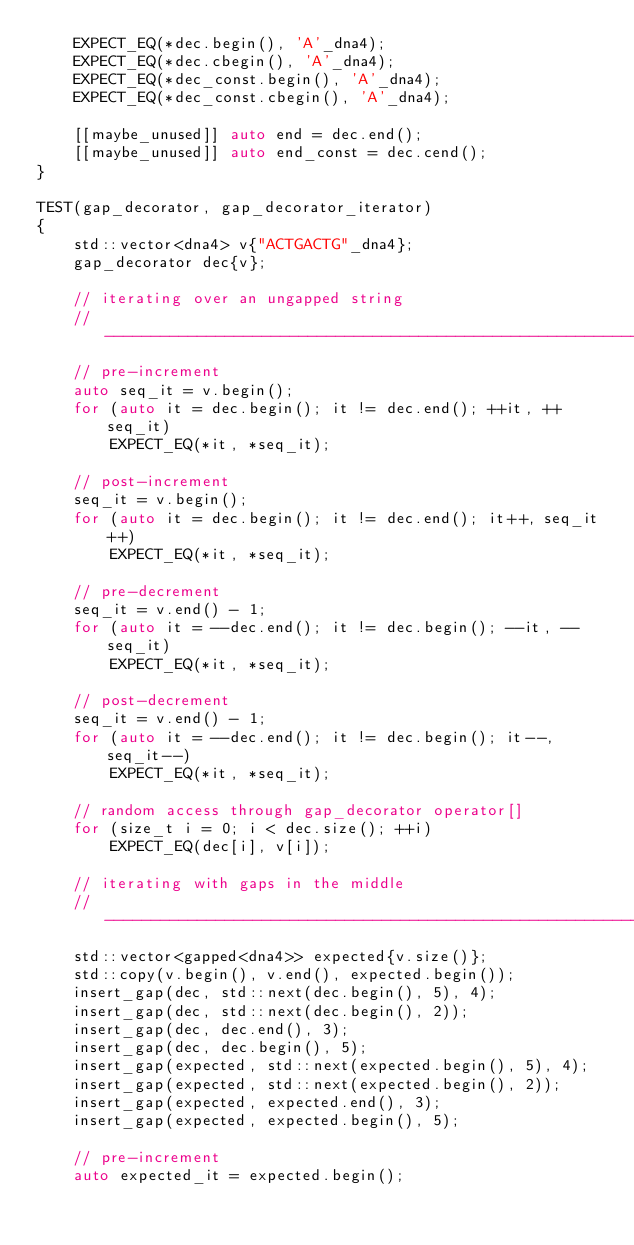<code> <loc_0><loc_0><loc_500><loc_500><_C++_>    EXPECT_EQ(*dec.begin(), 'A'_dna4);
    EXPECT_EQ(*dec.cbegin(), 'A'_dna4);
    EXPECT_EQ(*dec_const.begin(), 'A'_dna4);
    EXPECT_EQ(*dec_const.cbegin(), 'A'_dna4);

    [[maybe_unused]] auto end = dec.end();
    [[maybe_unused]] auto end_const = dec.cend();
}

TEST(gap_decorator, gap_decorator_iterator)
{
    std::vector<dna4> v{"ACTGACTG"_dna4};
    gap_decorator dec{v};

    // iterating over an ungapped string
    // -------------------------------------------------------------------------
    // pre-increment
    auto seq_it = v.begin();
    for (auto it = dec.begin(); it != dec.end(); ++it, ++seq_it)
        EXPECT_EQ(*it, *seq_it);

    // post-increment
    seq_it = v.begin();
    for (auto it = dec.begin(); it != dec.end(); it++, seq_it++)
        EXPECT_EQ(*it, *seq_it);

    // pre-decrement
    seq_it = v.end() - 1;
    for (auto it = --dec.end(); it != dec.begin(); --it, --seq_it)
        EXPECT_EQ(*it, *seq_it);

    // post-decrement
    seq_it = v.end() - 1;
    for (auto it = --dec.end(); it != dec.begin(); it--, seq_it--)
        EXPECT_EQ(*it, *seq_it);

    // random access through gap_decorator operator[]
    for (size_t i = 0; i < dec.size(); ++i)
        EXPECT_EQ(dec[i], v[i]);

    // iterating with gaps in the middle
    // -------------------------------------------------------------------------
    std::vector<gapped<dna4>> expected{v.size()};
    std::copy(v.begin(), v.end(), expected.begin());
    insert_gap(dec, std::next(dec.begin(), 5), 4);
    insert_gap(dec, std::next(dec.begin(), 2));
    insert_gap(dec, dec.end(), 3);
    insert_gap(dec, dec.begin(), 5);
    insert_gap(expected, std::next(expected.begin(), 5), 4);
    insert_gap(expected, std::next(expected.begin(), 2));
    insert_gap(expected, expected.end(), 3);
    insert_gap(expected, expected.begin(), 5);

    // pre-increment
    auto expected_it = expected.begin();</code> 